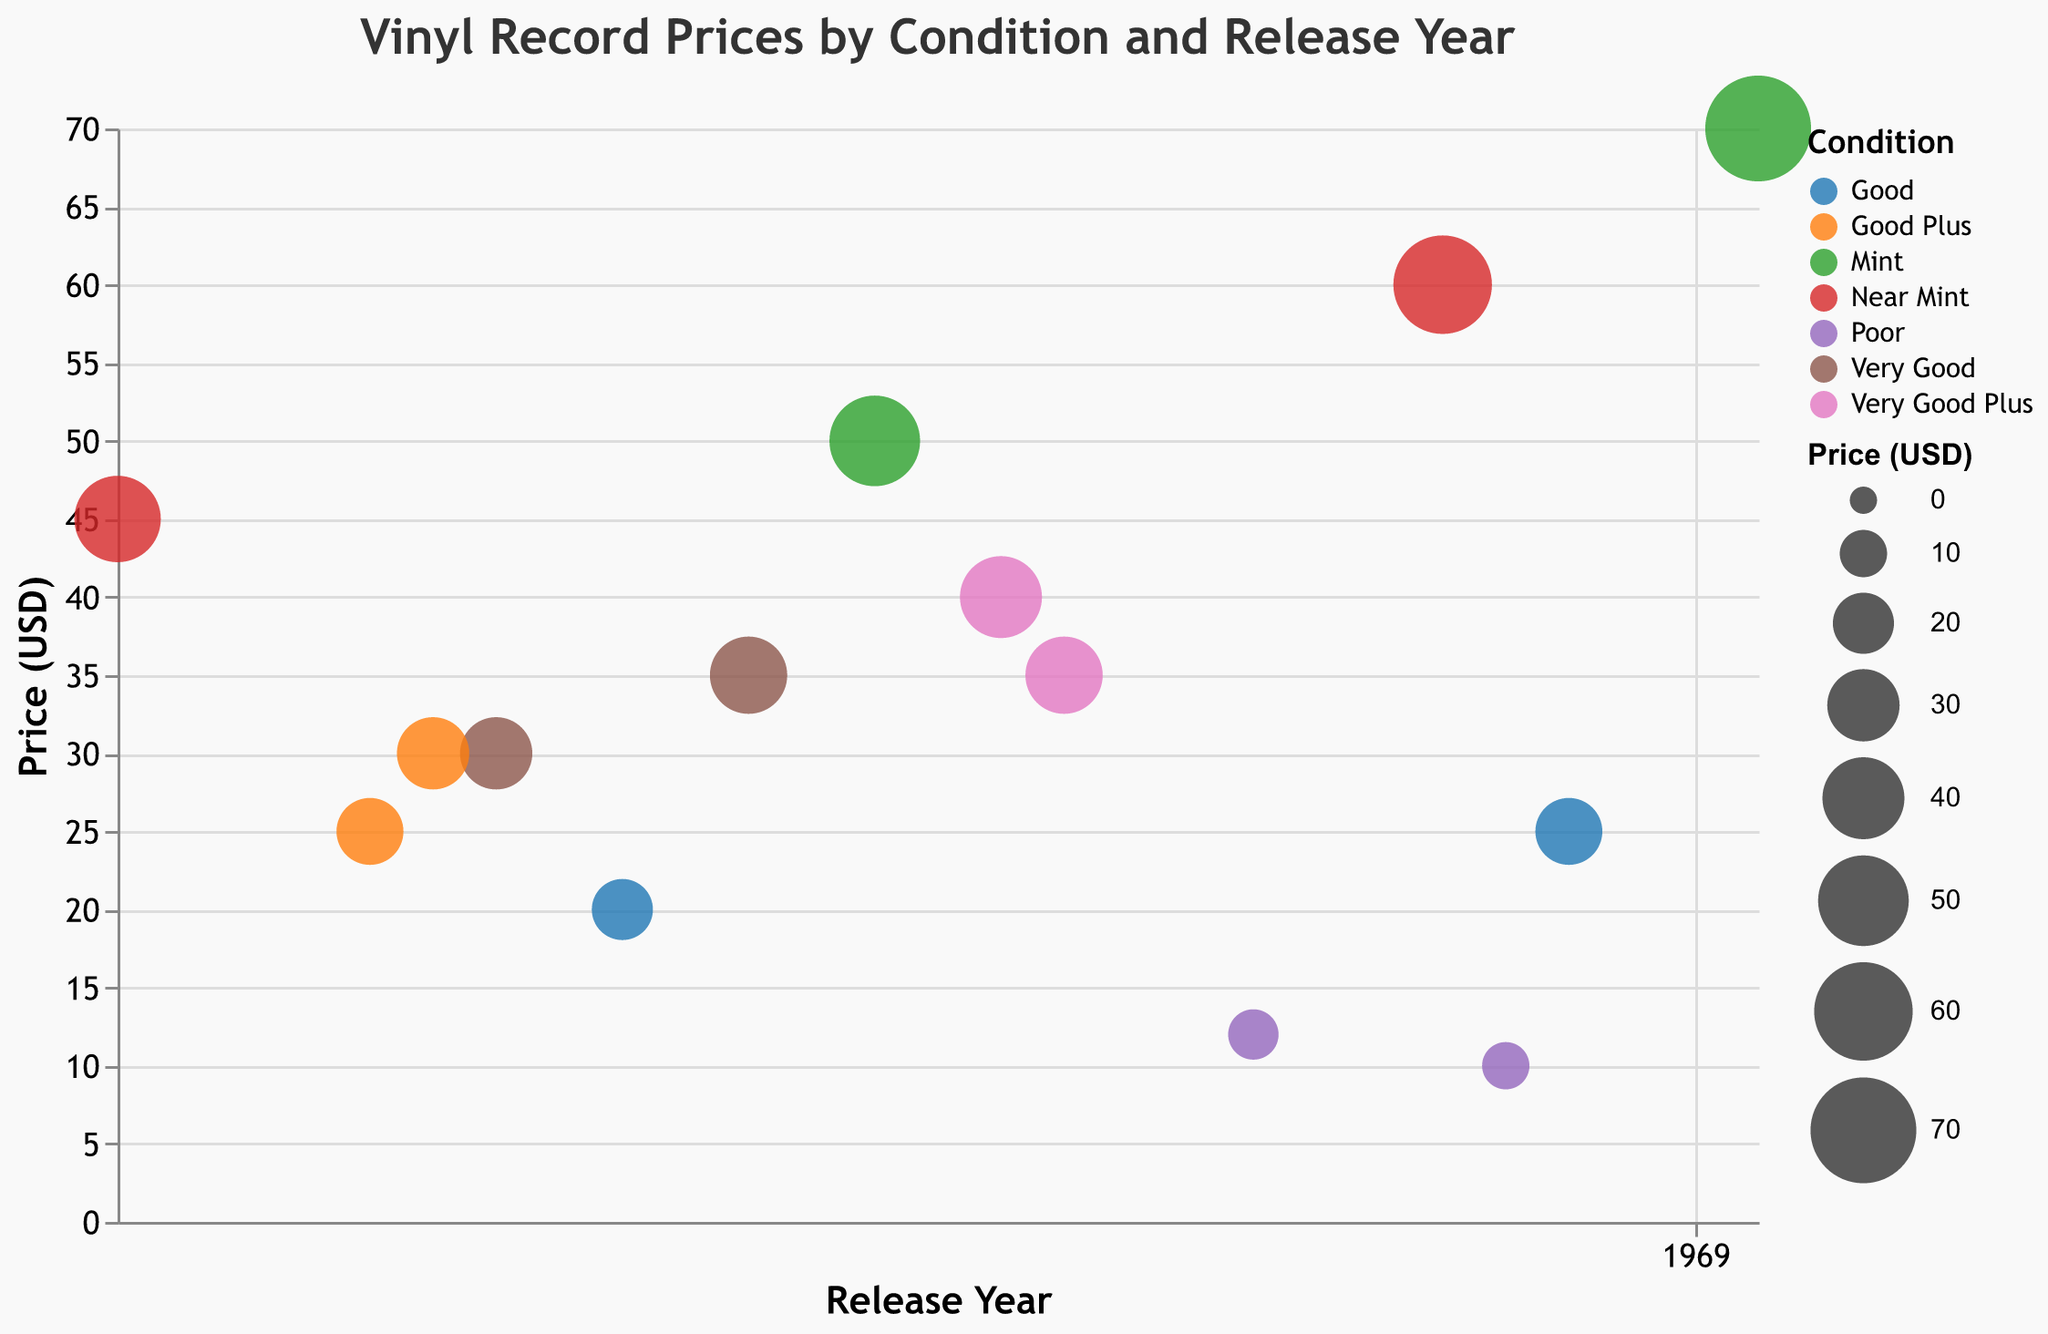What is the title of the chart? The title is usually located at the top center of the chart. In this case, it reads "Vinyl Record Prices by Condition and Release Year".
Answer: Vinyl Record Prices by Condition and Release Year How does the chart differentiate between different record conditions? The chart uses different colors to represent different record conditions. Each condition is assigned a unique color from the category10 color scheme.
Answer: Different colors Which vinyl record has the highest price? To find the highest priced vinyl record, look at the largest circle. The tooltip or size of the circle can indicate its price. In this chart, Nirvana's "Nevermind" has the highest price of $70.
Answer: Nirvana - Nevermind What is the release year and condition of "Led Zeppelin - IV"? Each data point has a tooltip that provides detailed information. By referencing the tooltip for "Led Zeppelin - IV", it shows the release year is 1971 and the condition is Very Good.
Answer: 1971, Very Good How many records in Poor condition are shown in the chart? Poor condition records can be identified by their unique color. Count the circles with this color. There are two records: "U2 - The Joshua Tree" and "Madonna - Madonna".
Answer: 2 What is the average price of Mint condition records? Identify the records in Mint condition (using color), and then calculate their average price. The records are "Fleetwood Mac - Rumours" ($50) and "Nirvana - Nevermind" ($70), so (50 + 70) / 2 = 60.
Answer: $60 Which record in Near Mint condition has the highest price and what is that price? Compare the sizes of the circles for Near Mint condition records. The largest circle represents the highest price, which is "Metallica - Master of Puppets" priced at $60.
Answer: Metallica - Master of Puppets, $60 How does the price of "Pink Floyd - The Dark Side of the Moon" compare to "The Smiths - Rank"? Both records are in Good condition, compare their prices by referring to the size of the circles or tooltips. "Pink Floyd - The Dark Side of the Moon" is priced at $20, and "The Smiths - Rank" is priced at $25.
Answer: The Smiths - Rank is more expensive What is the condition of the record released in 1986, and what is its price? Use the x-axis to locate the year 1986, then refer to the tooltip of the corresponding circle. The record is "Metallica - Master of Puppets" with Near Mint condition and priced at $60.
Answer: Near Mint, $60 